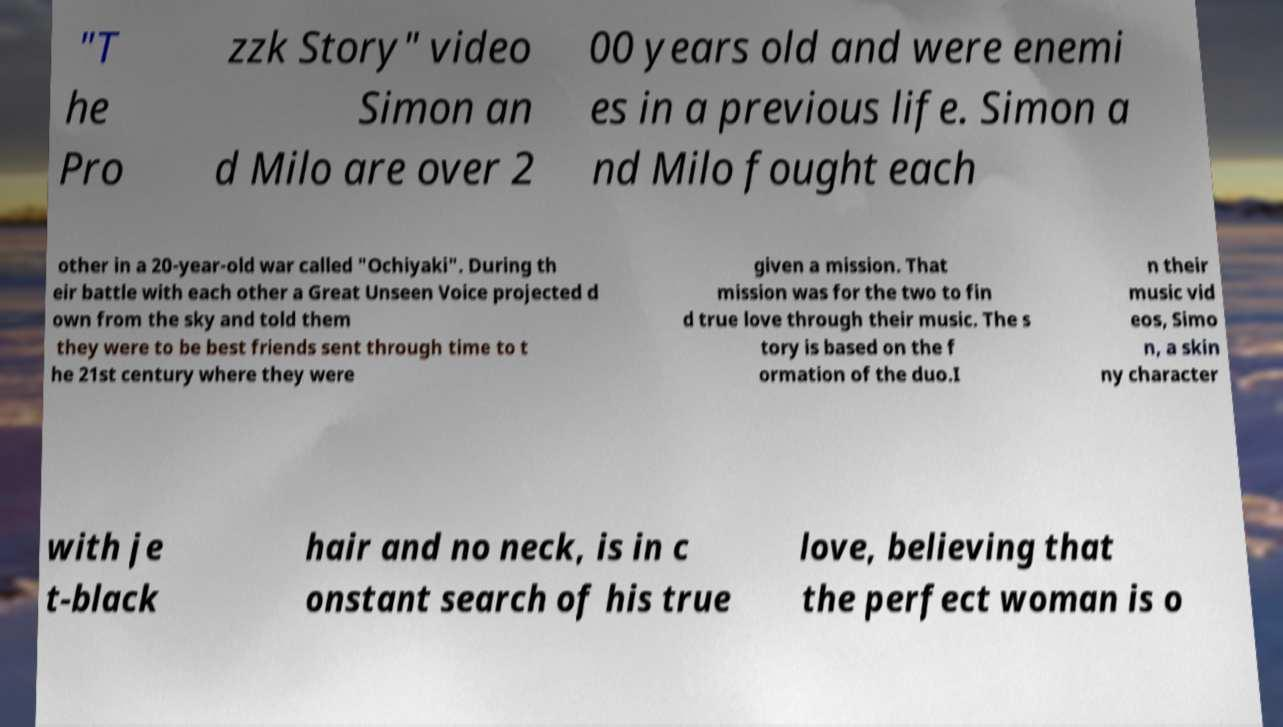Could you extract and type out the text from this image? "T he Pro zzk Story" video Simon an d Milo are over 2 00 years old and were enemi es in a previous life. Simon a nd Milo fought each other in a 20-year-old war called "Ochiyaki". During th eir battle with each other a Great Unseen Voice projected d own from the sky and told them they were to be best friends sent through time to t he 21st century where they were given a mission. That mission was for the two to fin d true love through their music. The s tory is based on the f ormation of the duo.I n their music vid eos, Simo n, a skin ny character with je t-black hair and no neck, is in c onstant search of his true love, believing that the perfect woman is o 